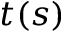<formula> <loc_0><loc_0><loc_500><loc_500>t ( s )</formula> 